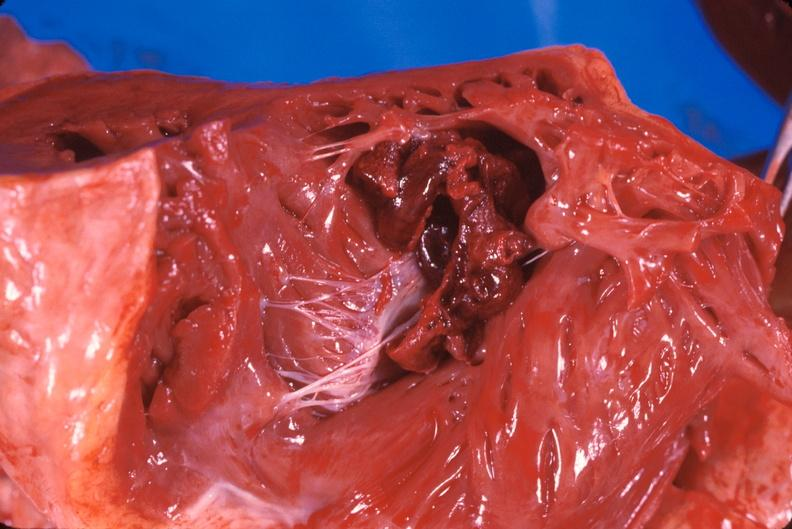what is present?
Answer the question using a single word or phrase. Heart 